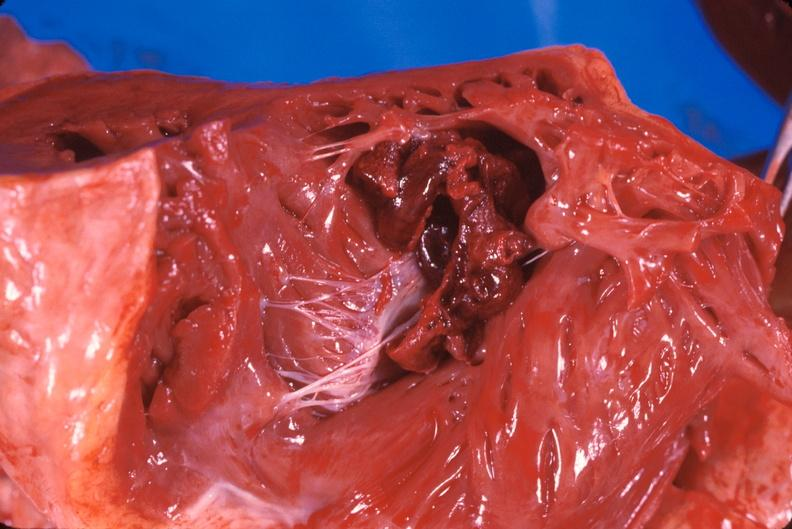what is present?
Answer the question using a single word or phrase. Heart 